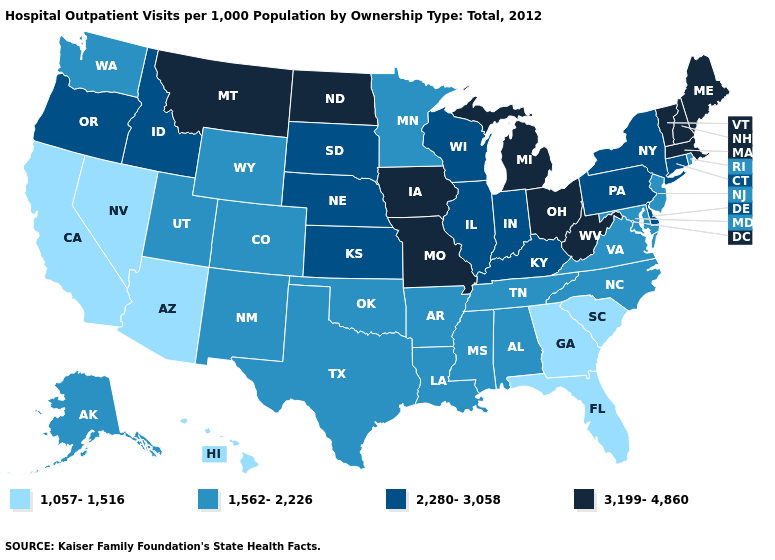Does the first symbol in the legend represent the smallest category?
Answer briefly. Yes. Name the states that have a value in the range 3,199-4,860?
Answer briefly. Iowa, Maine, Massachusetts, Michigan, Missouri, Montana, New Hampshire, North Dakota, Ohio, Vermont, West Virginia. Does Georgia have the lowest value in the USA?
Write a very short answer. Yes. What is the value of Wyoming?
Keep it brief. 1,562-2,226. Does Idaho have the highest value in the USA?
Keep it brief. No. What is the highest value in the USA?
Keep it brief. 3,199-4,860. What is the value of Texas?
Keep it brief. 1,562-2,226. What is the highest value in states that border Idaho?
Write a very short answer. 3,199-4,860. Name the states that have a value in the range 3,199-4,860?
Concise answer only. Iowa, Maine, Massachusetts, Michigan, Missouri, Montana, New Hampshire, North Dakota, Ohio, Vermont, West Virginia. Does South Carolina have a higher value than Oregon?
Be succinct. No. Name the states that have a value in the range 1,562-2,226?
Give a very brief answer. Alabama, Alaska, Arkansas, Colorado, Louisiana, Maryland, Minnesota, Mississippi, New Jersey, New Mexico, North Carolina, Oklahoma, Rhode Island, Tennessee, Texas, Utah, Virginia, Washington, Wyoming. Among the states that border Rhode Island , which have the highest value?
Quick response, please. Massachusetts. Name the states that have a value in the range 2,280-3,058?
Concise answer only. Connecticut, Delaware, Idaho, Illinois, Indiana, Kansas, Kentucky, Nebraska, New York, Oregon, Pennsylvania, South Dakota, Wisconsin. Which states have the lowest value in the West?
Give a very brief answer. Arizona, California, Hawaii, Nevada. Name the states that have a value in the range 3,199-4,860?
Keep it brief. Iowa, Maine, Massachusetts, Michigan, Missouri, Montana, New Hampshire, North Dakota, Ohio, Vermont, West Virginia. 